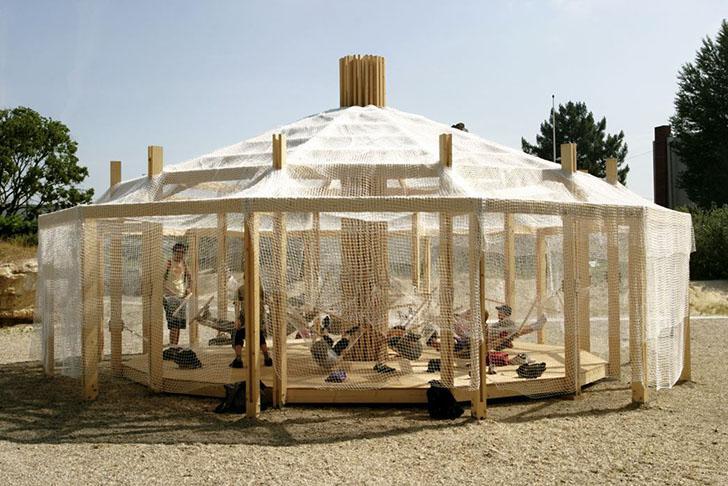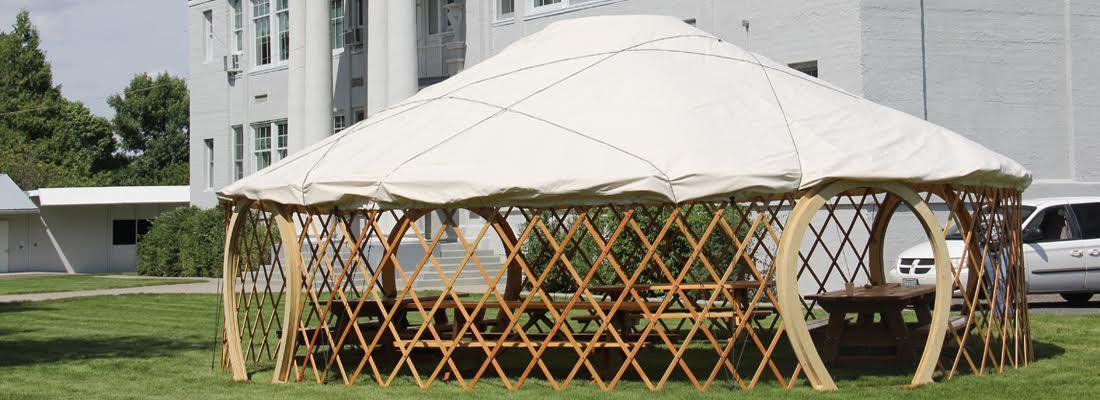The first image is the image on the left, the second image is the image on the right. Examine the images to the left and right. Is the description "All images show the outside of a yurt." accurate? Answer yes or no. Yes. The first image is the image on the left, the second image is the image on the right. Analyze the images presented: Is the assertion "At least one image shows the exterior of a round yurt-type structure that is not fully enclosed, showing its wooden framework." valid? Answer yes or no. Yes. 